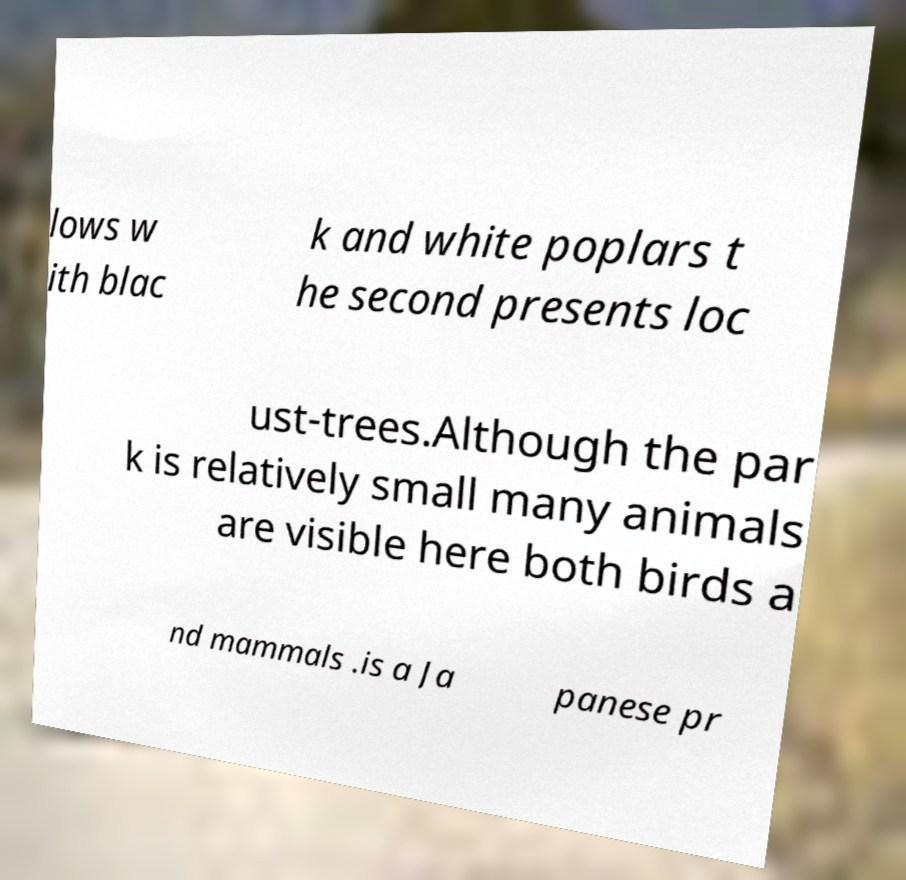There's text embedded in this image that I need extracted. Can you transcribe it verbatim? lows w ith blac k and white poplars t he second presents loc ust-trees.Although the par k is relatively small many animals are visible here both birds a nd mammals .is a Ja panese pr 